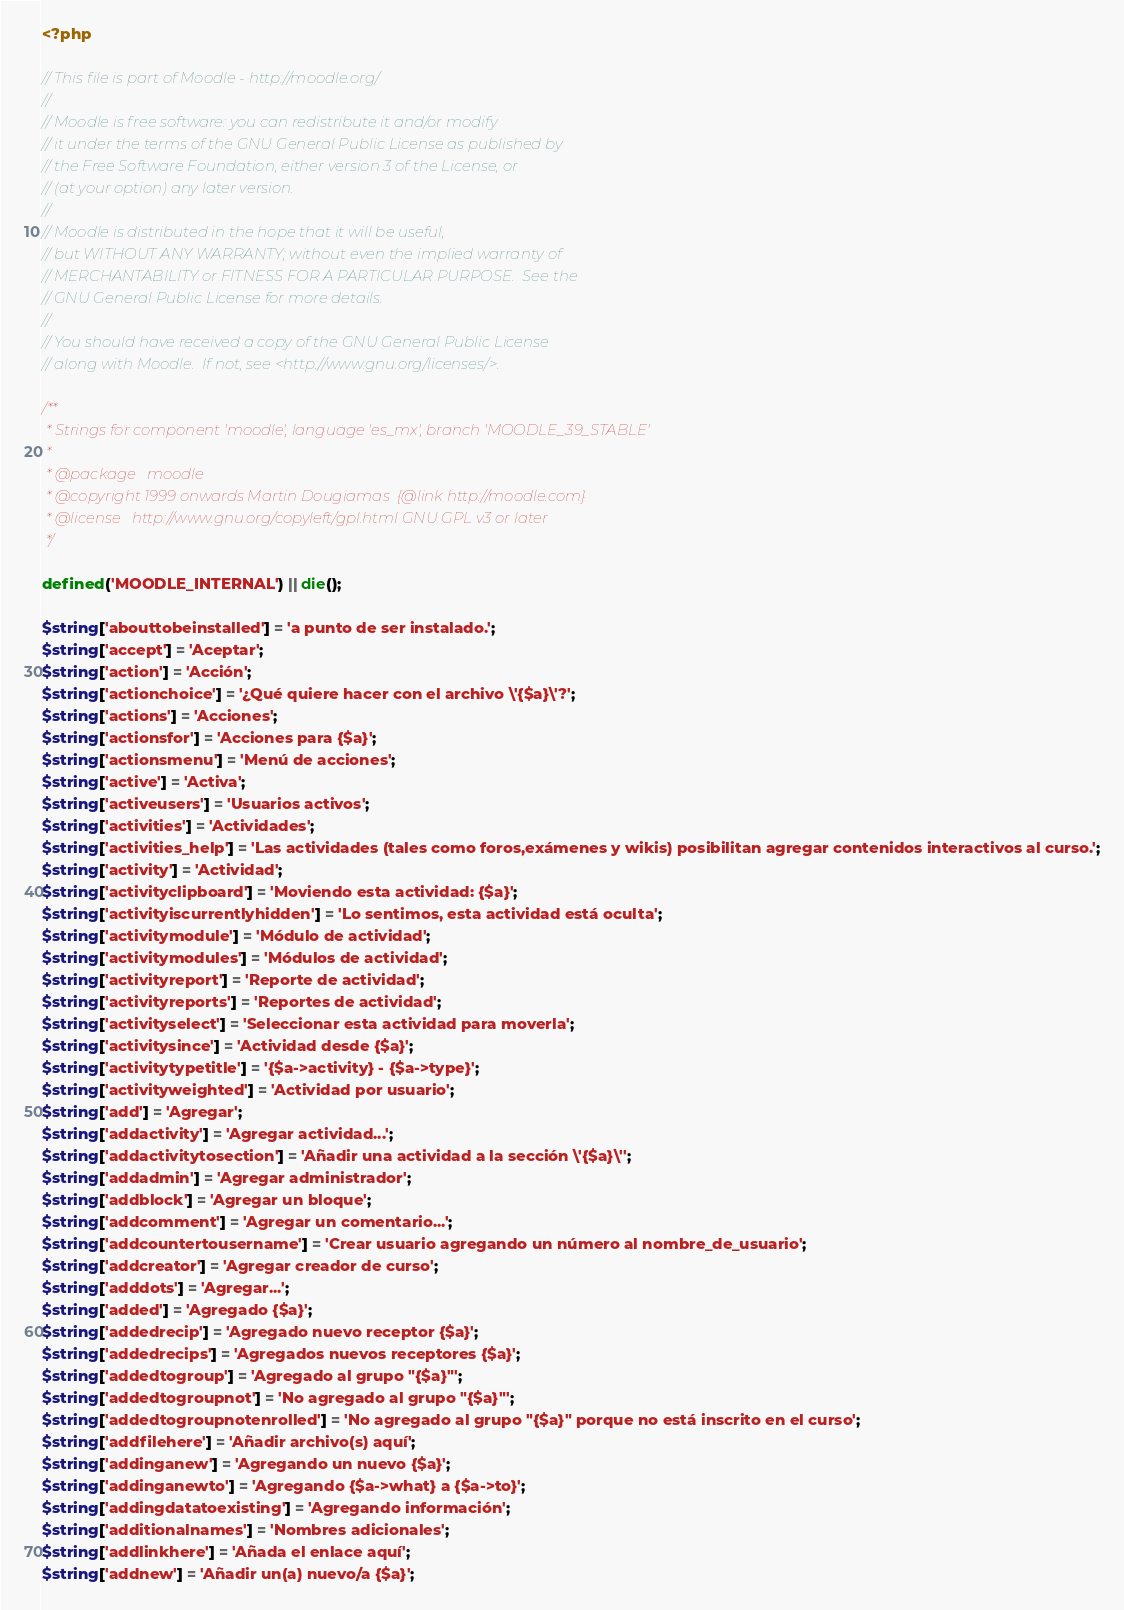Convert code to text. <code><loc_0><loc_0><loc_500><loc_500><_PHP_><?php

// This file is part of Moodle - http://moodle.org/
//
// Moodle is free software: you can redistribute it and/or modify
// it under the terms of the GNU General Public License as published by
// the Free Software Foundation, either version 3 of the License, or
// (at your option) any later version.
//
// Moodle is distributed in the hope that it will be useful,
// but WITHOUT ANY WARRANTY; without even the implied warranty of
// MERCHANTABILITY or FITNESS FOR A PARTICULAR PURPOSE.  See the
// GNU General Public License for more details.
//
// You should have received a copy of the GNU General Public License
// along with Moodle.  If not, see <http://www.gnu.org/licenses/>.

/**
 * Strings for component 'moodle', language 'es_mx', branch 'MOODLE_39_STABLE'
 *
 * @package   moodle
 * @copyright 1999 onwards Martin Dougiamas  {@link http://moodle.com}
 * @license   http://www.gnu.org/copyleft/gpl.html GNU GPL v3 or later
 */

defined('MOODLE_INTERNAL') || die();

$string['abouttobeinstalled'] = 'a punto de ser instalado.';
$string['accept'] = 'Aceptar';
$string['action'] = 'Acción';
$string['actionchoice'] = '¿Qué quiere hacer con el archivo \'{$a}\'?';
$string['actions'] = 'Acciones';
$string['actionsfor'] = 'Acciones para {$a}';
$string['actionsmenu'] = 'Menú de acciones';
$string['active'] = 'Activa';
$string['activeusers'] = 'Usuarios activos';
$string['activities'] = 'Actividades';
$string['activities_help'] = 'Las actividades (tales como foros,exámenes y wikis) posibilitan agregar contenidos interactivos al curso.';
$string['activity'] = 'Actividad';
$string['activityclipboard'] = 'Moviendo esta actividad: {$a}';
$string['activityiscurrentlyhidden'] = 'Lo sentimos, esta actividad está oculta';
$string['activitymodule'] = 'Módulo de actividad';
$string['activitymodules'] = 'Módulos de actividad';
$string['activityreport'] = 'Reporte de actividad';
$string['activityreports'] = 'Reportes de actividad';
$string['activityselect'] = 'Seleccionar esta actividad para moverla';
$string['activitysince'] = 'Actividad desde {$a}';
$string['activitytypetitle'] = '{$a->activity} - {$a->type}';
$string['activityweighted'] = 'Actividad por usuario';
$string['add'] = 'Agregar';
$string['addactivity'] = 'Agregar actividad...';
$string['addactivitytosection'] = 'Añadir una actividad a la sección \'{$a}\'';
$string['addadmin'] = 'Agregar administrador';
$string['addblock'] = 'Agregar un bloque';
$string['addcomment'] = 'Agregar un comentario...';
$string['addcountertousername'] = 'Crear usuario agregando un número al nombre_de_usuario';
$string['addcreator'] = 'Agregar creador de curso';
$string['adddots'] = 'Agregar...';
$string['added'] = 'Agregado {$a}';
$string['addedrecip'] = 'Agregado nuevo receptor {$a}';
$string['addedrecips'] = 'Agregados nuevos receptores {$a}';
$string['addedtogroup'] = 'Agregado al grupo "{$a}"';
$string['addedtogroupnot'] = 'No agregado al grupo "{$a}"';
$string['addedtogroupnotenrolled'] = 'No agregado al grupo "{$a}" porque no está inscrito en el curso';
$string['addfilehere'] = 'Añadir archivo(s) aquí';
$string['addinganew'] = 'Agregando un nuevo {$a}';
$string['addinganewto'] = 'Agregando {$a->what} a {$a->to}';
$string['addingdatatoexisting'] = 'Agregando información';
$string['additionalnames'] = 'Nombres adicionales';
$string['addlinkhere'] = 'Añada el enlace aquí';
$string['addnew'] = 'Añadir un(a) nuevo/a {$a}';</code> 